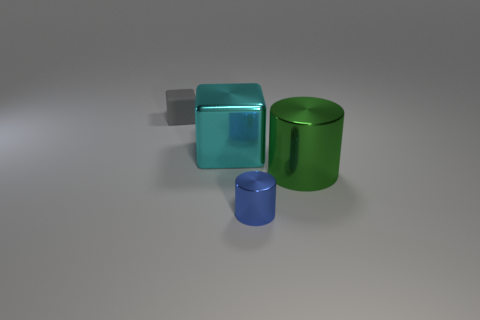There is a tiny metal object; what shape is it? The small object appears to be a cylinder, characterized by its circular base and smooth cylindrical surface. 